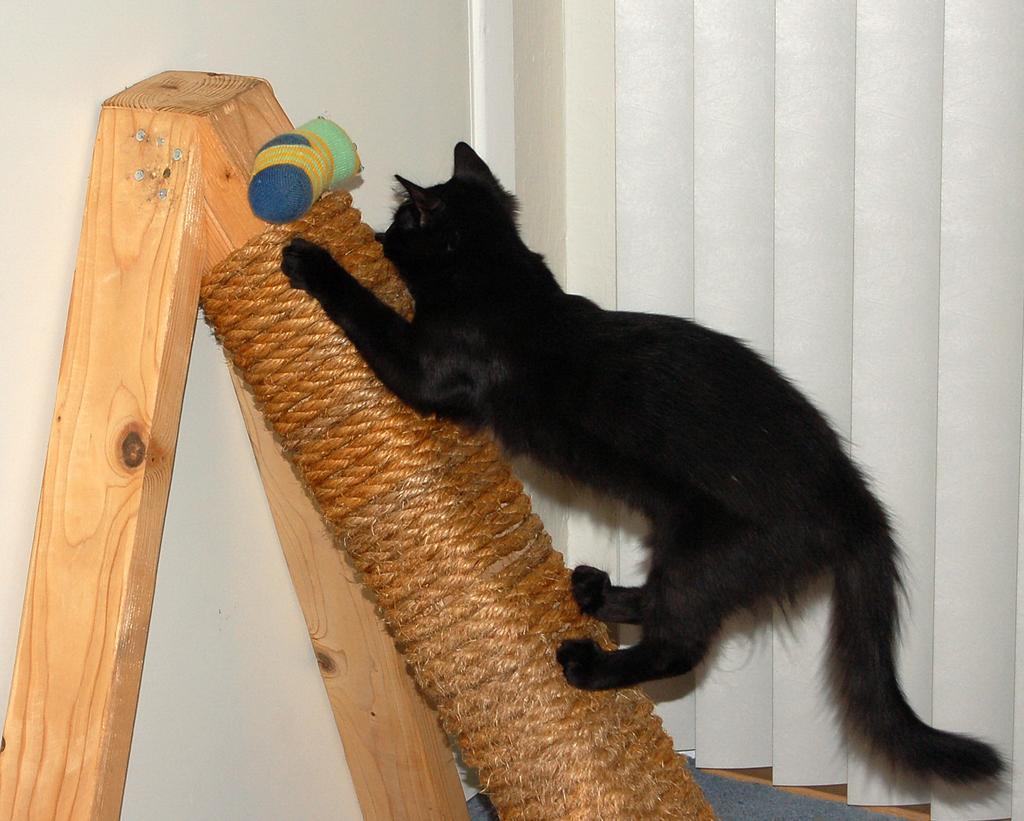How would you summarize this image in a sentence or two? This picture might be taken inside the room. In this image, in the middle there is a cat climbing on the wood rod. On the right side, we can see a curtain which is in white color. On the left side, there is a wall. 